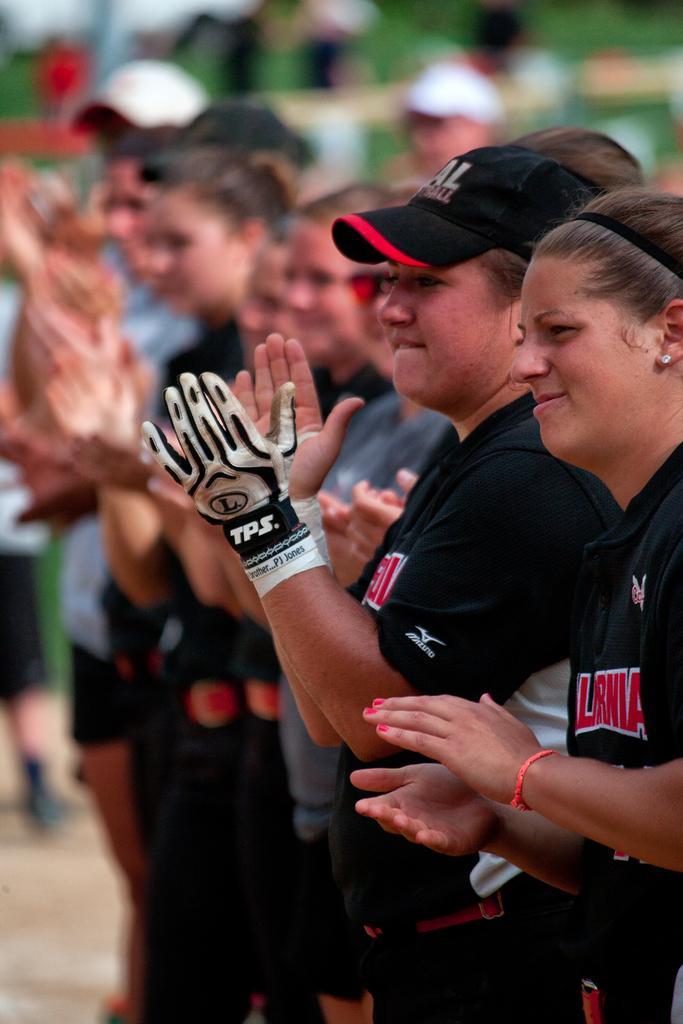In one or two sentences, can you explain what this image depicts? In this image there are people standing and clapping. 